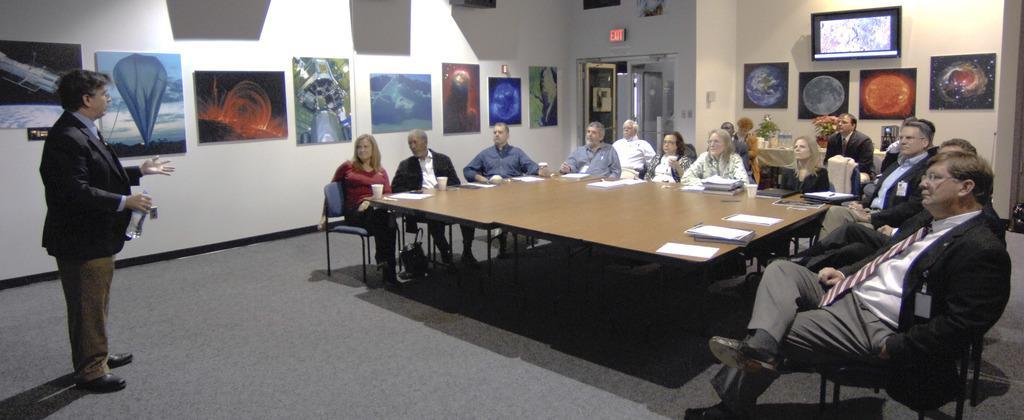Please provide a concise description of this image. On the background of the picture we can see a wall and few frames over it. This is a door and a exit sign board. here we can see a man standing and holding a bottle in his hand and explaining something to these persons. Th9is is a floor. Here we can see all the persons sitting on chairs in front of a table and on the table we can see papers , glasses. Here we can see a house plant on the table and few bottles. This is a television. 